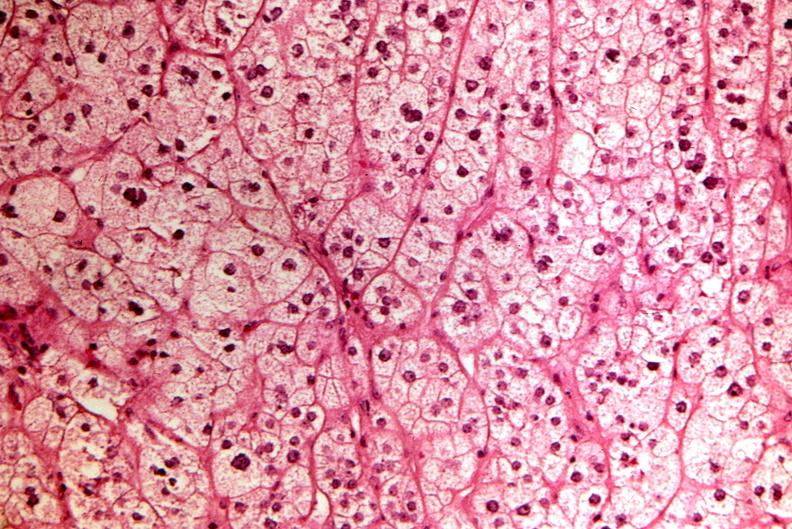where is this part in the figure?
Answer the question using a single word or phrase. Endocrine system 